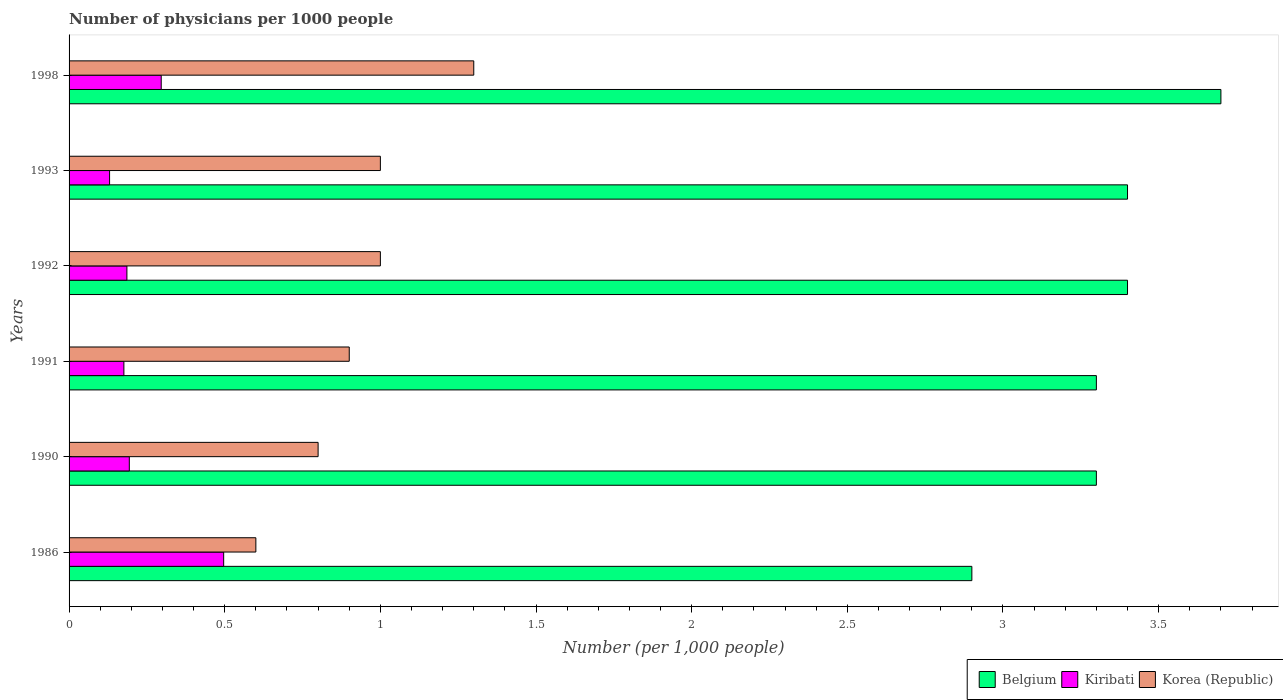How many groups of bars are there?
Offer a terse response. 6. How many bars are there on the 6th tick from the bottom?
Keep it short and to the point. 3. What is the number of physicians in Kiribati in 1991?
Make the answer very short. 0.18. Across all years, what is the minimum number of physicians in Belgium?
Ensure brevity in your answer.  2.9. In which year was the number of physicians in Kiribati maximum?
Keep it short and to the point. 1986. What is the average number of physicians in Belgium per year?
Make the answer very short. 3.33. In the year 1991, what is the difference between the number of physicians in Kiribati and number of physicians in Korea (Republic)?
Ensure brevity in your answer.  -0.72. What is the ratio of the number of physicians in Korea (Republic) in 1990 to that in 1991?
Keep it short and to the point. 0.89. Is the number of physicians in Kiribati in 1990 less than that in 1991?
Your response must be concise. No. What is the difference between the highest and the second highest number of physicians in Korea (Republic)?
Keep it short and to the point. 0.3. What is the difference between the highest and the lowest number of physicians in Belgium?
Your answer should be very brief. 0.8. In how many years, is the number of physicians in Kiribati greater than the average number of physicians in Kiribati taken over all years?
Provide a short and direct response. 2. What does the 2nd bar from the bottom in 1990 represents?
Ensure brevity in your answer.  Kiribati. Is it the case that in every year, the sum of the number of physicians in Belgium and number of physicians in Korea (Republic) is greater than the number of physicians in Kiribati?
Give a very brief answer. Yes. How many bars are there?
Your answer should be very brief. 18. What is the difference between two consecutive major ticks on the X-axis?
Give a very brief answer. 0.5. What is the title of the graph?
Your response must be concise. Number of physicians per 1000 people. What is the label or title of the X-axis?
Give a very brief answer. Number (per 1,0 people). What is the label or title of the Y-axis?
Ensure brevity in your answer.  Years. What is the Number (per 1,000 people) in Kiribati in 1986?
Give a very brief answer. 0.5. What is the Number (per 1,000 people) of Belgium in 1990?
Provide a short and direct response. 3.3. What is the Number (per 1,000 people) in Kiribati in 1990?
Your answer should be very brief. 0.19. What is the Number (per 1,000 people) of Korea (Republic) in 1990?
Keep it short and to the point. 0.8. What is the Number (per 1,000 people) in Belgium in 1991?
Keep it short and to the point. 3.3. What is the Number (per 1,000 people) in Kiribati in 1991?
Provide a short and direct response. 0.18. What is the Number (per 1,000 people) of Kiribati in 1992?
Offer a terse response. 0.19. What is the Number (per 1,000 people) in Korea (Republic) in 1992?
Ensure brevity in your answer.  1. What is the Number (per 1,000 people) in Kiribati in 1993?
Give a very brief answer. 0.13. What is the Number (per 1,000 people) of Korea (Republic) in 1993?
Your answer should be very brief. 1. What is the Number (per 1,000 people) in Kiribati in 1998?
Offer a terse response. 0.3. What is the Number (per 1,000 people) in Korea (Republic) in 1998?
Keep it short and to the point. 1.3. Across all years, what is the maximum Number (per 1,000 people) of Belgium?
Ensure brevity in your answer.  3.7. Across all years, what is the maximum Number (per 1,000 people) in Kiribati?
Make the answer very short. 0.5. Across all years, what is the minimum Number (per 1,000 people) in Kiribati?
Offer a terse response. 0.13. Across all years, what is the minimum Number (per 1,000 people) in Korea (Republic)?
Make the answer very short. 0.6. What is the total Number (per 1,000 people) in Belgium in the graph?
Offer a terse response. 20. What is the total Number (per 1,000 people) of Kiribati in the graph?
Provide a short and direct response. 1.48. What is the total Number (per 1,000 people) in Korea (Republic) in the graph?
Ensure brevity in your answer.  5.6. What is the difference between the Number (per 1,000 people) of Kiribati in 1986 and that in 1990?
Provide a succinct answer. 0.3. What is the difference between the Number (per 1,000 people) of Kiribati in 1986 and that in 1991?
Give a very brief answer. 0.32. What is the difference between the Number (per 1,000 people) of Korea (Republic) in 1986 and that in 1991?
Provide a succinct answer. -0.3. What is the difference between the Number (per 1,000 people) in Belgium in 1986 and that in 1992?
Your response must be concise. -0.5. What is the difference between the Number (per 1,000 people) in Kiribati in 1986 and that in 1992?
Offer a terse response. 0.31. What is the difference between the Number (per 1,000 people) in Korea (Republic) in 1986 and that in 1992?
Offer a very short reply. -0.4. What is the difference between the Number (per 1,000 people) of Belgium in 1986 and that in 1993?
Offer a terse response. -0.5. What is the difference between the Number (per 1,000 people) of Kiribati in 1986 and that in 1993?
Keep it short and to the point. 0.37. What is the difference between the Number (per 1,000 people) in Korea (Republic) in 1986 and that in 1993?
Offer a very short reply. -0.4. What is the difference between the Number (per 1,000 people) in Belgium in 1986 and that in 1998?
Your answer should be compact. -0.8. What is the difference between the Number (per 1,000 people) in Kiribati in 1986 and that in 1998?
Offer a very short reply. 0.2. What is the difference between the Number (per 1,000 people) of Korea (Republic) in 1986 and that in 1998?
Your answer should be very brief. -0.7. What is the difference between the Number (per 1,000 people) of Kiribati in 1990 and that in 1991?
Ensure brevity in your answer.  0.02. What is the difference between the Number (per 1,000 people) of Korea (Republic) in 1990 and that in 1991?
Provide a succinct answer. -0.1. What is the difference between the Number (per 1,000 people) of Belgium in 1990 and that in 1992?
Your answer should be compact. -0.1. What is the difference between the Number (per 1,000 people) of Kiribati in 1990 and that in 1992?
Your answer should be very brief. 0.01. What is the difference between the Number (per 1,000 people) of Belgium in 1990 and that in 1993?
Offer a terse response. -0.1. What is the difference between the Number (per 1,000 people) in Kiribati in 1990 and that in 1993?
Your answer should be very brief. 0.06. What is the difference between the Number (per 1,000 people) in Korea (Republic) in 1990 and that in 1993?
Offer a terse response. -0.2. What is the difference between the Number (per 1,000 people) of Kiribati in 1990 and that in 1998?
Offer a very short reply. -0.1. What is the difference between the Number (per 1,000 people) in Korea (Republic) in 1990 and that in 1998?
Offer a very short reply. -0.5. What is the difference between the Number (per 1,000 people) in Belgium in 1991 and that in 1992?
Your answer should be very brief. -0.1. What is the difference between the Number (per 1,000 people) in Kiribati in 1991 and that in 1992?
Offer a very short reply. -0.01. What is the difference between the Number (per 1,000 people) of Korea (Republic) in 1991 and that in 1992?
Your response must be concise. -0.1. What is the difference between the Number (per 1,000 people) of Kiribati in 1991 and that in 1993?
Offer a terse response. 0.05. What is the difference between the Number (per 1,000 people) of Belgium in 1991 and that in 1998?
Keep it short and to the point. -0.4. What is the difference between the Number (per 1,000 people) in Kiribati in 1991 and that in 1998?
Offer a terse response. -0.12. What is the difference between the Number (per 1,000 people) of Korea (Republic) in 1991 and that in 1998?
Provide a succinct answer. -0.4. What is the difference between the Number (per 1,000 people) in Belgium in 1992 and that in 1993?
Give a very brief answer. 0. What is the difference between the Number (per 1,000 people) of Kiribati in 1992 and that in 1993?
Keep it short and to the point. 0.06. What is the difference between the Number (per 1,000 people) of Korea (Republic) in 1992 and that in 1993?
Make the answer very short. 0. What is the difference between the Number (per 1,000 people) in Kiribati in 1992 and that in 1998?
Provide a short and direct response. -0.11. What is the difference between the Number (per 1,000 people) in Belgium in 1993 and that in 1998?
Make the answer very short. -0.3. What is the difference between the Number (per 1,000 people) in Kiribati in 1993 and that in 1998?
Your answer should be very brief. -0.17. What is the difference between the Number (per 1,000 people) in Korea (Republic) in 1993 and that in 1998?
Make the answer very short. -0.3. What is the difference between the Number (per 1,000 people) of Belgium in 1986 and the Number (per 1,000 people) of Kiribati in 1990?
Keep it short and to the point. 2.71. What is the difference between the Number (per 1,000 people) of Kiribati in 1986 and the Number (per 1,000 people) of Korea (Republic) in 1990?
Ensure brevity in your answer.  -0.3. What is the difference between the Number (per 1,000 people) in Belgium in 1986 and the Number (per 1,000 people) in Kiribati in 1991?
Give a very brief answer. 2.72. What is the difference between the Number (per 1,000 people) of Belgium in 1986 and the Number (per 1,000 people) of Korea (Republic) in 1991?
Offer a terse response. 2. What is the difference between the Number (per 1,000 people) in Kiribati in 1986 and the Number (per 1,000 people) in Korea (Republic) in 1991?
Your answer should be compact. -0.4. What is the difference between the Number (per 1,000 people) of Belgium in 1986 and the Number (per 1,000 people) of Kiribati in 1992?
Offer a very short reply. 2.71. What is the difference between the Number (per 1,000 people) of Belgium in 1986 and the Number (per 1,000 people) of Korea (Republic) in 1992?
Provide a short and direct response. 1.9. What is the difference between the Number (per 1,000 people) of Kiribati in 1986 and the Number (per 1,000 people) of Korea (Republic) in 1992?
Provide a succinct answer. -0.5. What is the difference between the Number (per 1,000 people) in Belgium in 1986 and the Number (per 1,000 people) in Kiribati in 1993?
Ensure brevity in your answer.  2.77. What is the difference between the Number (per 1,000 people) in Belgium in 1986 and the Number (per 1,000 people) in Korea (Republic) in 1993?
Provide a succinct answer. 1.9. What is the difference between the Number (per 1,000 people) of Kiribati in 1986 and the Number (per 1,000 people) of Korea (Republic) in 1993?
Keep it short and to the point. -0.5. What is the difference between the Number (per 1,000 people) in Belgium in 1986 and the Number (per 1,000 people) in Kiribati in 1998?
Give a very brief answer. 2.6. What is the difference between the Number (per 1,000 people) in Belgium in 1986 and the Number (per 1,000 people) in Korea (Republic) in 1998?
Provide a short and direct response. 1.6. What is the difference between the Number (per 1,000 people) of Kiribati in 1986 and the Number (per 1,000 people) of Korea (Republic) in 1998?
Offer a terse response. -0.8. What is the difference between the Number (per 1,000 people) in Belgium in 1990 and the Number (per 1,000 people) in Kiribati in 1991?
Offer a terse response. 3.12. What is the difference between the Number (per 1,000 people) in Kiribati in 1990 and the Number (per 1,000 people) in Korea (Republic) in 1991?
Keep it short and to the point. -0.71. What is the difference between the Number (per 1,000 people) of Belgium in 1990 and the Number (per 1,000 people) of Kiribati in 1992?
Offer a terse response. 3.11. What is the difference between the Number (per 1,000 people) of Kiribati in 1990 and the Number (per 1,000 people) of Korea (Republic) in 1992?
Make the answer very short. -0.81. What is the difference between the Number (per 1,000 people) in Belgium in 1990 and the Number (per 1,000 people) in Kiribati in 1993?
Ensure brevity in your answer.  3.17. What is the difference between the Number (per 1,000 people) in Kiribati in 1990 and the Number (per 1,000 people) in Korea (Republic) in 1993?
Give a very brief answer. -0.81. What is the difference between the Number (per 1,000 people) of Belgium in 1990 and the Number (per 1,000 people) of Kiribati in 1998?
Offer a very short reply. 3. What is the difference between the Number (per 1,000 people) of Belgium in 1990 and the Number (per 1,000 people) of Korea (Republic) in 1998?
Your response must be concise. 2. What is the difference between the Number (per 1,000 people) of Kiribati in 1990 and the Number (per 1,000 people) of Korea (Republic) in 1998?
Provide a short and direct response. -1.11. What is the difference between the Number (per 1,000 people) in Belgium in 1991 and the Number (per 1,000 people) in Kiribati in 1992?
Provide a short and direct response. 3.11. What is the difference between the Number (per 1,000 people) in Kiribati in 1991 and the Number (per 1,000 people) in Korea (Republic) in 1992?
Give a very brief answer. -0.82. What is the difference between the Number (per 1,000 people) in Belgium in 1991 and the Number (per 1,000 people) in Kiribati in 1993?
Give a very brief answer. 3.17. What is the difference between the Number (per 1,000 people) of Kiribati in 1991 and the Number (per 1,000 people) of Korea (Republic) in 1993?
Keep it short and to the point. -0.82. What is the difference between the Number (per 1,000 people) in Belgium in 1991 and the Number (per 1,000 people) in Kiribati in 1998?
Your answer should be compact. 3. What is the difference between the Number (per 1,000 people) of Kiribati in 1991 and the Number (per 1,000 people) of Korea (Republic) in 1998?
Your response must be concise. -1.12. What is the difference between the Number (per 1,000 people) of Belgium in 1992 and the Number (per 1,000 people) of Kiribati in 1993?
Ensure brevity in your answer.  3.27. What is the difference between the Number (per 1,000 people) in Kiribati in 1992 and the Number (per 1,000 people) in Korea (Republic) in 1993?
Ensure brevity in your answer.  -0.81. What is the difference between the Number (per 1,000 people) in Belgium in 1992 and the Number (per 1,000 people) in Kiribati in 1998?
Keep it short and to the point. 3.1. What is the difference between the Number (per 1,000 people) of Belgium in 1992 and the Number (per 1,000 people) of Korea (Republic) in 1998?
Offer a terse response. 2.1. What is the difference between the Number (per 1,000 people) of Kiribati in 1992 and the Number (per 1,000 people) of Korea (Republic) in 1998?
Offer a very short reply. -1.11. What is the difference between the Number (per 1,000 people) in Belgium in 1993 and the Number (per 1,000 people) in Kiribati in 1998?
Your answer should be very brief. 3.1. What is the difference between the Number (per 1,000 people) in Belgium in 1993 and the Number (per 1,000 people) in Korea (Republic) in 1998?
Offer a terse response. 2.1. What is the difference between the Number (per 1,000 people) of Kiribati in 1993 and the Number (per 1,000 people) of Korea (Republic) in 1998?
Keep it short and to the point. -1.17. What is the average Number (per 1,000 people) of Kiribati per year?
Make the answer very short. 0.25. What is the average Number (per 1,000 people) of Korea (Republic) per year?
Your response must be concise. 0.93. In the year 1986, what is the difference between the Number (per 1,000 people) in Belgium and Number (per 1,000 people) in Kiribati?
Provide a short and direct response. 2.4. In the year 1986, what is the difference between the Number (per 1,000 people) in Kiribati and Number (per 1,000 people) in Korea (Republic)?
Provide a succinct answer. -0.1. In the year 1990, what is the difference between the Number (per 1,000 people) of Belgium and Number (per 1,000 people) of Kiribati?
Offer a terse response. 3.11. In the year 1990, what is the difference between the Number (per 1,000 people) in Kiribati and Number (per 1,000 people) in Korea (Republic)?
Give a very brief answer. -0.61. In the year 1991, what is the difference between the Number (per 1,000 people) of Belgium and Number (per 1,000 people) of Kiribati?
Give a very brief answer. 3.12. In the year 1991, what is the difference between the Number (per 1,000 people) of Belgium and Number (per 1,000 people) of Korea (Republic)?
Offer a terse response. 2.4. In the year 1991, what is the difference between the Number (per 1,000 people) of Kiribati and Number (per 1,000 people) of Korea (Republic)?
Your response must be concise. -0.72. In the year 1992, what is the difference between the Number (per 1,000 people) of Belgium and Number (per 1,000 people) of Kiribati?
Provide a succinct answer. 3.21. In the year 1992, what is the difference between the Number (per 1,000 people) in Belgium and Number (per 1,000 people) in Korea (Republic)?
Provide a short and direct response. 2.4. In the year 1992, what is the difference between the Number (per 1,000 people) of Kiribati and Number (per 1,000 people) of Korea (Republic)?
Your answer should be very brief. -0.81. In the year 1993, what is the difference between the Number (per 1,000 people) of Belgium and Number (per 1,000 people) of Kiribati?
Make the answer very short. 3.27. In the year 1993, what is the difference between the Number (per 1,000 people) of Kiribati and Number (per 1,000 people) of Korea (Republic)?
Ensure brevity in your answer.  -0.87. In the year 1998, what is the difference between the Number (per 1,000 people) in Belgium and Number (per 1,000 people) in Kiribati?
Provide a succinct answer. 3.4. In the year 1998, what is the difference between the Number (per 1,000 people) of Belgium and Number (per 1,000 people) of Korea (Republic)?
Provide a succinct answer. 2.4. In the year 1998, what is the difference between the Number (per 1,000 people) in Kiribati and Number (per 1,000 people) in Korea (Republic)?
Your answer should be very brief. -1. What is the ratio of the Number (per 1,000 people) in Belgium in 1986 to that in 1990?
Keep it short and to the point. 0.88. What is the ratio of the Number (per 1,000 people) of Kiribati in 1986 to that in 1990?
Offer a very short reply. 2.57. What is the ratio of the Number (per 1,000 people) in Belgium in 1986 to that in 1991?
Ensure brevity in your answer.  0.88. What is the ratio of the Number (per 1,000 people) of Kiribati in 1986 to that in 1991?
Your response must be concise. 2.82. What is the ratio of the Number (per 1,000 people) of Belgium in 1986 to that in 1992?
Make the answer very short. 0.85. What is the ratio of the Number (per 1,000 people) in Kiribati in 1986 to that in 1992?
Provide a succinct answer. 2.67. What is the ratio of the Number (per 1,000 people) in Korea (Republic) in 1986 to that in 1992?
Make the answer very short. 0.6. What is the ratio of the Number (per 1,000 people) in Belgium in 1986 to that in 1993?
Your response must be concise. 0.85. What is the ratio of the Number (per 1,000 people) of Kiribati in 1986 to that in 1993?
Make the answer very short. 3.82. What is the ratio of the Number (per 1,000 people) in Belgium in 1986 to that in 1998?
Keep it short and to the point. 0.78. What is the ratio of the Number (per 1,000 people) in Kiribati in 1986 to that in 1998?
Provide a succinct answer. 1.68. What is the ratio of the Number (per 1,000 people) in Korea (Republic) in 1986 to that in 1998?
Provide a succinct answer. 0.46. What is the ratio of the Number (per 1,000 people) of Kiribati in 1990 to that in 1991?
Your answer should be compact. 1.1. What is the ratio of the Number (per 1,000 people) in Belgium in 1990 to that in 1992?
Keep it short and to the point. 0.97. What is the ratio of the Number (per 1,000 people) in Kiribati in 1990 to that in 1992?
Make the answer very short. 1.04. What is the ratio of the Number (per 1,000 people) in Korea (Republic) in 1990 to that in 1992?
Your answer should be compact. 0.8. What is the ratio of the Number (per 1,000 people) in Belgium in 1990 to that in 1993?
Keep it short and to the point. 0.97. What is the ratio of the Number (per 1,000 people) in Kiribati in 1990 to that in 1993?
Give a very brief answer. 1.49. What is the ratio of the Number (per 1,000 people) of Korea (Republic) in 1990 to that in 1993?
Offer a terse response. 0.8. What is the ratio of the Number (per 1,000 people) in Belgium in 1990 to that in 1998?
Your response must be concise. 0.89. What is the ratio of the Number (per 1,000 people) in Kiribati in 1990 to that in 1998?
Offer a terse response. 0.65. What is the ratio of the Number (per 1,000 people) in Korea (Republic) in 1990 to that in 1998?
Your response must be concise. 0.62. What is the ratio of the Number (per 1,000 people) in Belgium in 1991 to that in 1992?
Give a very brief answer. 0.97. What is the ratio of the Number (per 1,000 people) in Kiribati in 1991 to that in 1992?
Provide a short and direct response. 0.95. What is the ratio of the Number (per 1,000 people) of Belgium in 1991 to that in 1993?
Make the answer very short. 0.97. What is the ratio of the Number (per 1,000 people) in Kiribati in 1991 to that in 1993?
Provide a succinct answer. 1.35. What is the ratio of the Number (per 1,000 people) of Korea (Republic) in 1991 to that in 1993?
Give a very brief answer. 0.9. What is the ratio of the Number (per 1,000 people) in Belgium in 1991 to that in 1998?
Make the answer very short. 0.89. What is the ratio of the Number (per 1,000 people) of Kiribati in 1991 to that in 1998?
Provide a short and direct response. 0.59. What is the ratio of the Number (per 1,000 people) of Korea (Republic) in 1991 to that in 1998?
Keep it short and to the point. 0.69. What is the ratio of the Number (per 1,000 people) of Belgium in 1992 to that in 1993?
Your response must be concise. 1. What is the ratio of the Number (per 1,000 people) in Kiribati in 1992 to that in 1993?
Provide a succinct answer. 1.43. What is the ratio of the Number (per 1,000 people) in Belgium in 1992 to that in 1998?
Make the answer very short. 0.92. What is the ratio of the Number (per 1,000 people) of Kiribati in 1992 to that in 1998?
Offer a terse response. 0.63. What is the ratio of the Number (per 1,000 people) of Korea (Republic) in 1992 to that in 1998?
Your response must be concise. 0.77. What is the ratio of the Number (per 1,000 people) in Belgium in 1993 to that in 1998?
Ensure brevity in your answer.  0.92. What is the ratio of the Number (per 1,000 people) in Kiribati in 1993 to that in 1998?
Give a very brief answer. 0.44. What is the ratio of the Number (per 1,000 people) of Korea (Republic) in 1993 to that in 1998?
Provide a succinct answer. 0.77. What is the difference between the highest and the second highest Number (per 1,000 people) in Kiribati?
Provide a short and direct response. 0.2. What is the difference between the highest and the second highest Number (per 1,000 people) of Korea (Republic)?
Keep it short and to the point. 0.3. What is the difference between the highest and the lowest Number (per 1,000 people) in Belgium?
Your response must be concise. 0.8. What is the difference between the highest and the lowest Number (per 1,000 people) of Kiribati?
Provide a succinct answer. 0.37. 